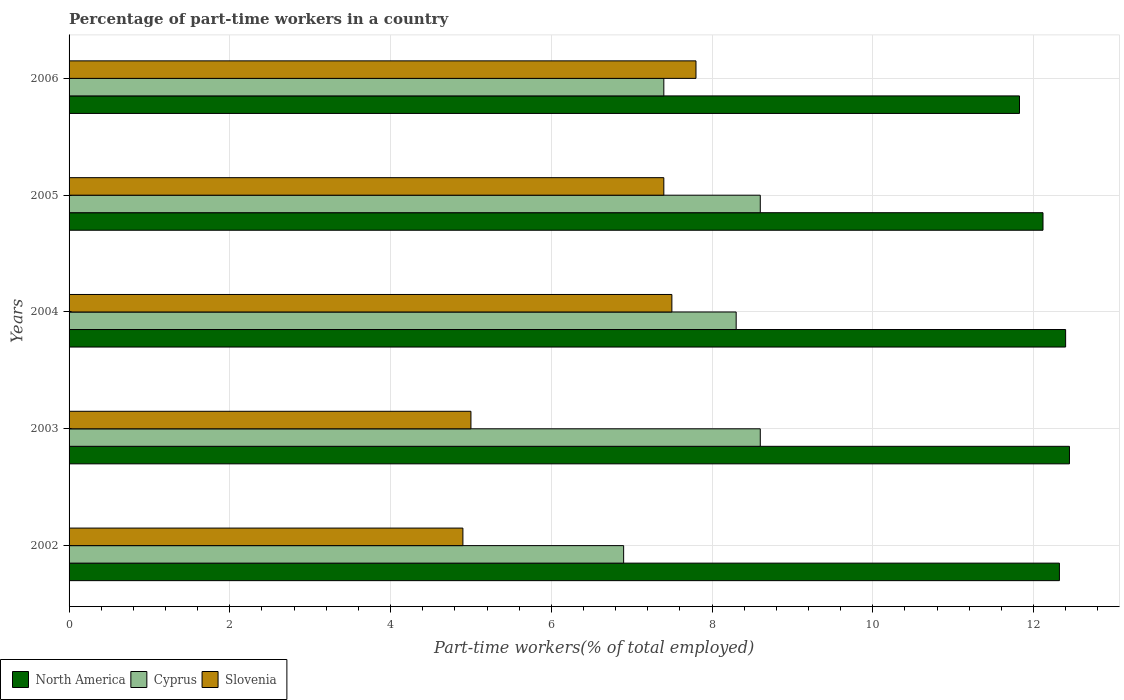Are the number of bars on each tick of the Y-axis equal?
Provide a short and direct response. Yes. In how many cases, is the number of bars for a given year not equal to the number of legend labels?
Offer a terse response. 0. What is the percentage of part-time workers in North America in 2005?
Keep it short and to the point. 12.12. Across all years, what is the maximum percentage of part-time workers in Cyprus?
Offer a very short reply. 8.6. Across all years, what is the minimum percentage of part-time workers in North America?
Offer a terse response. 11.83. What is the total percentage of part-time workers in Cyprus in the graph?
Offer a very short reply. 39.8. What is the difference between the percentage of part-time workers in Cyprus in 2004 and the percentage of part-time workers in Slovenia in 2005?
Give a very brief answer. 0.9. What is the average percentage of part-time workers in Slovenia per year?
Offer a terse response. 6.52. In the year 2003, what is the difference between the percentage of part-time workers in Slovenia and percentage of part-time workers in Cyprus?
Your response must be concise. -3.6. What is the ratio of the percentage of part-time workers in Slovenia in 2003 to that in 2005?
Provide a short and direct response. 0.68. What is the difference between the highest and the lowest percentage of part-time workers in Slovenia?
Your answer should be compact. 2.9. What does the 1st bar from the top in 2006 represents?
Your answer should be compact. Slovenia. What does the 1st bar from the bottom in 2003 represents?
Your response must be concise. North America. Is it the case that in every year, the sum of the percentage of part-time workers in North America and percentage of part-time workers in Cyprus is greater than the percentage of part-time workers in Slovenia?
Ensure brevity in your answer.  Yes. How many bars are there?
Give a very brief answer. 15. What is the difference between two consecutive major ticks on the X-axis?
Keep it short and to the point. 2. Are the values on the major ticks of X-axis written in scientific E-notation?
Your answer should be very brief. No. Does the graph contain any zero values?
Provide a succinct answer. No. Does the graph contain grids?
Provide a short and direct response. Yes. What is the title of the graph?
Your response must be concise. Percentage of part-time workers in a country. What is the label or title of the X-axis?
Provide a short and direct response. Part-time workers(% of total employed). What is the Part-time workers(% of total employed) of North America in 2002?
Offer a very short reply. 12.32. What is the Part-time workers(% of total employed) of Cyprus in 2002?
Keep it short and to the point. 6.9. What is the Part-time workers(% of total employed) of Slovenia in 2002?
Give a very brief answer. 4.9. What is the Part-time workers(% of total employed) of North America in 2003?
Offer a very short reply. 12.45. What is the Part-time workers(% of total employed) in Cyprus in 2003?
Make the answer very short. 8.6. What is the Part-time workers(% of total employed) in North America in 2004?
Offer a terse response. 12.4. What is the Part-time workers(% of total employed) in Cyprus in 2004?
Offer a terse response. 8.3. What is the Part-time workers(% of total employed) of Slovenia in 2004?
Provide a short and direct response. 7.5. What is the Part-time workers(% of total employed) of North America in 2005?
Provide a short and direct response. 12.12. What is the Part-time workers(% of total employed) of Cyprus in 2005?
Keep it short and to the point. 8.6. What is the Part-time workers(% of total employed) of Slovenia in 2005?
Your answer should be very brief. 7.4. What is the Part-time workers(% of total employed) of North America in 2006?
Provide a succinct answer. 11.83. What is the Part-time workers(% of total employed) of Cyprus in 2006?
Your response must be concise. 7.4. What is the Part-time workers(% of total employed) of Slovenia in 2006?
Provide a short and direct response. 7.8. Across all years, what is the maximum Part-time workers(% of total employed) of North America?
Provide a short and direct response. 12.45. Across all years, what is the maximum Part-time workers(% of total employed) of Cyprus?
Keep it short and to the point. 8.6. Across all years, what is the maximum Part-time workers(% of total employed) in Slovenia?
Ensure brevity in your answer.  7.8. Across all years, what is the minimum Part-time workers(% of total employed) of North America?
Offer a terse response. 11.83. Across all years, what is the minimum Part-time workers(% of total employed) of Cyprus?
Your response must be concise. 6.9. Across all years, what is the minimum Part-time workers(% of total employed) in Slovenia?
Provide a succinct answer. 4.9. What is the total Part-time workers(% of total employed) in North America in the graph?
Your response must be concise. 61.11. What is the total Part-time workers(% of total employed) in Cyprus in the graph?
Your answer should be compact. 39.8. What is the total Part-time workers(% of total employed) of Slovenia in the graph?
Keep it short and to the point. 32.6. What is the difference between the Part-time workers(% of total employed) in North America in 2002 and that in 2003?
Your answer should be very brief. -0.13. What is the difference between the Part-time workers(% of total employed) of North America in 2002 and that in 2004?
Make the answer very short. -0.08. What is the difference between the Part-time workers(% of total employed) of Cyprus in 2002 and that in 2004?
Give a very brief answer. -1.4. What is the difference between the Part-time workers(% of total employed) in North America in 2002 and that in 2005?
Offer a very short reply. 0.2. What is the difference between the Part-time workers(% of total employed) of Cyprus in 2002 and that in 2005?
Your response must be concise. -1.7. What is the difference between the Part-time workers(% of total employed) in North America in 2002 and that in 2006?
Offer a terse response. 0.5. What is the difference between the Part-time workers(% of total employed) of North America in 2003 and that in 2004?
Ensure brevity in your answer.  0.05. What is the difference between the Part-time workers(% of total employed) of Cyprus in 2003 and that in 2004?
Offer a terse response. 0.3. What is the difference between the Part-time workers(% of total employed) in Slovenia in 2003 and that in 2004?
Keep it short and to the point. -2.5. What is the difference between the Part-time workers(% of total employed) in North America in 2003 and that in 2005?
Your answer should be very brief. 0.33. What is the difference between the Part-time workers(% of total employed) in Cyprus in 2003 and that in 2005?
Give a very brief answer. 0. What is the difference between the Part-time workers(% of total employed) of North America in 2003 and that in 2006?
Offer a very short reply. 0.62. What is the difference between the Part-time workers(% of total employed) in North America in 2004 and that in 2005?
Offer a terse response. 0.28. What is the difference between the Part-time workers(% of total employed) of Slovenia in 2004 and that in 2005?
Keep it short and to the point. 0.1. What is the difference between the Part-time workers(% of total employed) in North America in 2004 and that in 2006?
Keep it short and to the point. 0.57. What is the difference between the Part-time workers(% of total employed) in Cyprus in 2004 and that in 2006?
Give a very brief answer. 0.9. What is the difference between the Part-time workers(% of total employed) of North America in 2005 and that in 2006?
Ensure brevity in your answer.  0.29. What is the difference between the Part-time workers(% of total employed) in Cyprus in 2005 and that in 2006?
Make the answer very short. 1.2. What is the difference between the Part-time workers(% of total employed) in North America in 2002 and the Part-time workers(% of total employed) in Cyprus in 2003?
Provide a succinct answer. 3.72. What is the difference between the Part-time workers(% of total employed) of North America in 2002 and the Part-time workers(% of total employed) of Slovenia in 2003?
Offer a terse response. 7.32. What is the difference between the Part-time workers(% of total employed) in North America in 2002 and the Part-time workers(% of total employed) in Cyprus in 2004?
Provide a succinct answer. 4.02. What is the difference between the Part-time workers(% of total employed) in North America in 2002 and the Part-time workers(% of total employed) in Slovenia in 2004?
Give a very brief answer. 4.82. What is the difference between the Part-time workers(% of total employed) of North America in 2002 and the Part-time workers(% of total employed) of Cyprus in 2005?
Keep it short and to the point. 3.72. What is the difference between the Part-time workers(% of total employed) of North America in 2002 and the Part-time workers(% of total employed) of Slovenia in 2005?
Offer a terse response. 4.92. What is the difference between the Part-time workers(% of total employed) in North America in 2002 and the Part-time workers(% of total employed) in Cyprus in 2006?
Ensure brevity in your answer.  4.92. What is the difference between the Part-time workers(% of total employed) in North America in 2002 and the Part-time workers(% of total employed) in Slovenia in 2006?
Offer a terse response. 4.52. What is the difference between the Part-time workers(% of total employed) in Cyprus in 2002 and the Part-time workers(% of total employed) in Slovenia in 2006?
Provide a succinct answer. -0.9. What is the difference between the Part-time workers(% of total employed) in North America in 2003 and the Part-time workers(% of total employed) in Cyprus in 2004?
Your response must be concise. 4.15. What is the difference between the Part-time workers(% of total employed) of North America in 2003 and the Part-time workers(% of total employed) of Slovenia in 2004?
Give a very brief answer. 4.95. What is the difference between the Part-time workers(% of total employed) in North America in 2003 and the Part-time workers(% of total employed) in Cyprus in 2005?
Offer a very short reply. 3.85. What is the difference between the Part-time workers(% of total employed) in North America in 2003 and the Part-time workers(% of total employed) in Slovenia in 2005?
Ensure brevity in your answer.  5.05. What is the difference between the Part-time workers(% of total employed) in Cyprus in 2003 and the Part-time workers(% of total employed) in Slovenia in 2005?
Ensure brevity in your answer.  1.2. What is the difference between the Part-time workers(% of total employed) in North America in 2003 and the Part-time workers(% of total employed) in Cyprus in 2006?
Offer a very short reply. 5.05. What is the difference between the Part-time workers(% of total employed) in North America in 2003 and the Part-time workers(% of total employed) in Slovenia in 2006?
Your response must be concise. 4.65. What is the difference between the Part-time workers(% of total employed) of Cyprus in 2003 and the Part-time workers(% of total employed) of Slovenia in 2006?
Offer a terse response. 0.8. What is the difference between the Part-time workers(% of total employed) of North America in 2004 and the Part-time workers(% of total employed) of Cyprus in 2005?
Offer a very short reply. 3.8. What is the difference between the Part-time workers(% of total employed) in North America in 2004 and the Part-time workers(% of total employed) in Slovenia in 2005?
Give a very brief answer. 5. What is the difference between the Part-time workers(% of total employed) of Cyprus in 2004 and the Part-time workers(% of total employed) of Slovenia in 2005?
Provide a succinct answer. 0.9. What is the difference between the Part-time workers(% of total employed) in North America in 2004 and the Part-time workers(% of total employed) in Cyprus in 2006?
Offer a terse response. 5. What is the difference between the Part-time workers(% of total employed) in North America in 2004 and the Part-time workers(% of total employed) in Slovenia in 2006?
Give a very brief answer. 4.6. What is the difference between the Part-time workers(% of total employed) of Cyprus in 2004 and the Part-time workers(% of total employed) of Slovenia in 2006?
Your answer should be very brief. 0.5. What is the difference between the Part-time workers(% of total employed) of North America in 2005 and the Part-time workers(% of total employed) of Cyprus in 2006?
Provide a succinct answer. 4.72. What is the difference between the Part-time workers(% of total employed) of North America in 2005 and the Part-time workers(% of total employed) of Slovenia in 2006?
Provide a succinct answer. 4.32. What is the difference between the Part-time workers(% of total employed) in Cyprus in 2005 and the Part-time workers(% of total employed) in Slovenia in 2006?
Your answer should be compact. 0.8. What is the average Part-time workers(% of total employed) of North America per year?
Offer a terse response. 12.22. What is the average Part-time workers(% of total employed) of Cyprus per year?
Your answer should be compact. 7.96. What is the average Part-time workers(% of total employed) of Slovenia per year?
Offer a very short reply. 6.52. In the year 2002, what is the difference between the Part-time workers(% of total employed) in North America and Part-time workers(% of total employed) in Cyprus?
Your answer should be very brief. 5.42. In the year 2002, what is the difference between the Part-time workers(% of total employed) of North America and Part-time workers(% of total employed) of Slovenia?
Ensure brevity in your answer.  7.42. In the year 2002, what is the difference between the Part-time workers(% of total employed) in Cyprus and Part-time workers(% of total employed) in Slovenia?
Provide a succinct answer. 2. In the year 2003, what is the difference between the Part-time workers(% of total employed) in North America and Part-time workers(% of total employed) in Cyprus?
Give a very brief answer. 3.85. In the year 2003, what is the difference between the Part-time workers(% of total employed) in North America and Part-time workers(% of total employed) in Slovenia?
Ensure brevity in your answer.  7.45. In the year 2003, what is the difference between the Part-time workers(% of total employed) in Cyprus and Part-time workers(% of total employed) in Slovenia?
Your response must be concise. 3.6. In the year 2004, what is the difference between the Part-time workers(% of total employed) in North America and Part-time workers(% of total employed) in Cyprus?
Make the answer very short. 4.1. In the year 2004, what is the difference between the Part-time workers(% of total employed) of North America and Part-time workers(% of total employed) of Slovenia?
Your answer should be compact. 4.9. In the year 2004, what is the difference between the Part-time workers(% of total employed) of Cyprus and Part-time workers(% of total employed) of Slovenia?
Your answer should be very brief. 0.8. In the year 2005, what is the difference between the Part-time workers(% of total employed) of North America and Part-time workers(% of total employed) of Cyprus?
Give a very brief answer. 3.52. In the year 2005, what is the difference between the Part-time workers(% of total employed) in North America and Part-time workers(% of total employed) in Slovenia?
Provide a succinct answer. 4.72. In the year 2005, what is the difference between the Part-time workers(% of total employed) in Cyprus and Part-time workers(% of total employed) in Slovenia?
Your answer should be very brief. 1.2. In the year 2006, what is the difference between the Part-time workers(% of total employed) in North America and Part-time workers(% of total employed) in Cyprus?
Make the answer very short. 4.43. In the year 2006, what is the difference between the Part-time workers(% of total employed) in North America and Part-time workers(% of total employed) in Slovenia?
Offer a terse response. 4.03. In the year 2006, what is the difference between the Part-time workers(% of total employed) of Cyprus and Part-time workers(% of total employed) of Slovenia?
Provide a succinct answer. -0.4. What is the ratio of the Part-time workers(% of total employed) of Cyprus in 2002 to that in 2003?
Your response must be concise. 0.8. What is the ratio of the Part-time workers(% of total employed) of Slovenia in 2002 to that in 2003?
Offer a very short reply. 0.98. What is the ratio of the Part-time workers(% of total employed) in Cyprus in 2002 to that in 2004?
Offer a terse response. 0.83. What is the ratio of the Part-time workers(% of total employed) of Slovenia in 2002 to that in 2004?
Offer a terse response. 0.65. What is the ratio of the Part-time workers(% of total employed) in North America in 2002 to that in 2005?
Give a very brief answer. 1.02. What is the ratio of the Part-time workers(% of total employed) in Cyprus in 2002 to that in 2005?
Provide a succinct answer. 0.8. What is the ratio of the Part-time workers(% of total employed) in Slovenia in 2002 to that in 2005?
Give a very brief answer. 0.66. What is the ratio of the Part-time workers(% of total employed) of North America in 2002 to that in 2006?
Give a very brief answer. 1.04. What is the ratio of the Part-time workers(% of total employed) of Cyprus in 2002 to that in 2006?
Your answer should be compact. 0.93. What is the ratio of the Part-time workers(% of total employed) in Slovenia in 2002 to that in 2006?
Your answer should be very brief. 0.63. What is the ratio of the Part-time workers(% of total employed) of Cyprus in 2003 to that in 2004?
Your response must be concise. 1.04. What is the ratio of the Part-time workers(% of total employed) in North America in 2003 to that in 2005?
Your response must be concise. 1.03. What is the ratio of the Part-time workers(% of total employed) in Cyprus in 2003 to that in 2005?
Offer a very short reply. 1. What is the ratio of the Part-time workers(% of total employed) of Slovenia in 2003 to that in 2005?
Your answer should be very brief. 0.68. What is the ratio of the Part-time workers(% of total employed) of North America in 2003 to that in 2006?
Make the answer very short. 1.05. What is the ratio of the Part-time workers(% of total employed) of Cyprus in 2003 to that in 2006?
Keep it short and to the point. 1.16. What is the ratio of the Part-time workers(% of total employed) in Slovenia in 2003 to that in 2006?
Your answer should be compact. 0.64. What is the ratio of the Part-time workers(% of total employed) of North America in 2004 to that in 2005?
Provide a succinct answer. 1.02. What is the ratio of the Part-time workers(% of total employed) of Cyprus in 2004 to that in 2005?
Give a very brief answer. 0.97. What is the ratio of the Part-time workers(% of total employed) of Slovenia in 2004 to that in 2005?
Make the answer very short. 1.01. What is the ratio of the Part-time workers(% of total employed) of North America in 2004 to that in 2006?
Offer a terse response. 1.05. What is the ratio of the Part-time workers(% of total employed) in Cyprus in 2004 to that in 2006?
Make the answer very short. 1.12. What is the ratio of the Part-time workers(% of total employed) in Slovenia in 2004 to that in 2006?
Offer a very short reply. 0.96. What is the ratio of the Part-time workers(% of total employed) of North America in 2005 to that in 2006?
Offer a very short reply. 1.02. What is the ratio of the Part-time workers(% of total employed) in Cyprus in 2005 to that in 2006?
Your answer should be very brief. 1.16. What is the ratio of the Part-time workers(% of total employed) in Slovenia in 2005 to that in 2006?
Make the answer very short. 0.95. What is the difference between the highest and the second highest Part-time workers(% of total employed) of North America?
Give a very brief answer. 0.05. What is the difference between the highest and the second highest Part-time workers(% of total employed) of Slovenia?
Make the answer very short. 0.3. What is the difference between the highest and the lowest Part-time workers(% of total employed) of North America?
Provide a succinct answer. 0.62. What is the difference between the highest and the lowest Part-time workers(% of total employed) of Cyprus?
Make the answer very short. 1.7. What is the difference between the highest and the lowest Part-time workers(% of total employed) in Slovenia?
Your response must be concise. 2.9. 